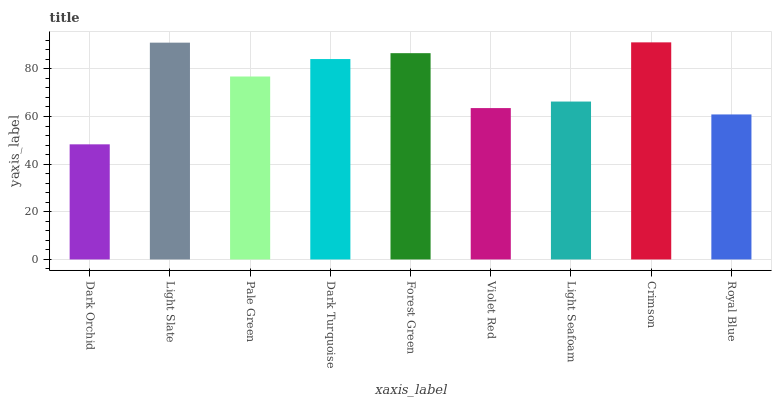Is Dark Orchid the minimum?
Answer yes or no. Yes. Is Crimson the maximum?
Answer yes or no. Yes. Is Light Slate the minimum?
Answer yes or no. No. Is Light Slate the maximum?
Answer yes or no. No. Is Light Slate greater than Dark Orchid?
Answer yes or no. Yes. Is Dark Orchid less than Light Slate?
Answer yes or no. Yes. Is Dark Orchid greater than Light Slate?
Answer yes or no. No. Is Light Slate less than Dark Orchid?
Answer yes or no. No. Is Pale Green the high median?
Answer yes or no. Yes. Is Pale Green the low median?
Answer yes or no. Yes. Is Forest Green the high median?
Answer yes or no. No. Is Violet Red the low median?
Answer yes or no. No. 